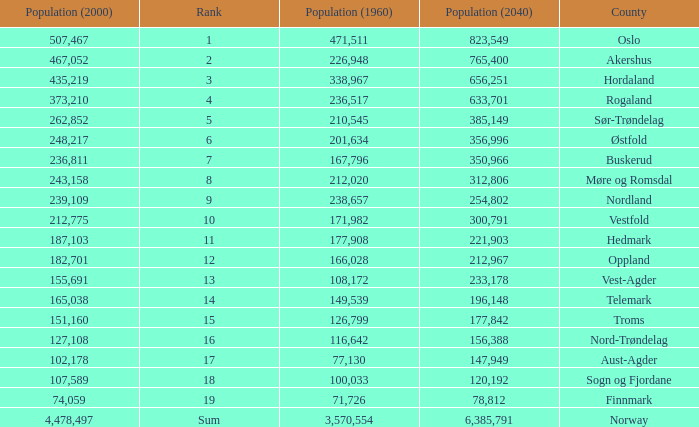What was the population of a county in 2040 that had a population less than 108,172 in 2000 and less than 107,589 in 1960? 2.0. 